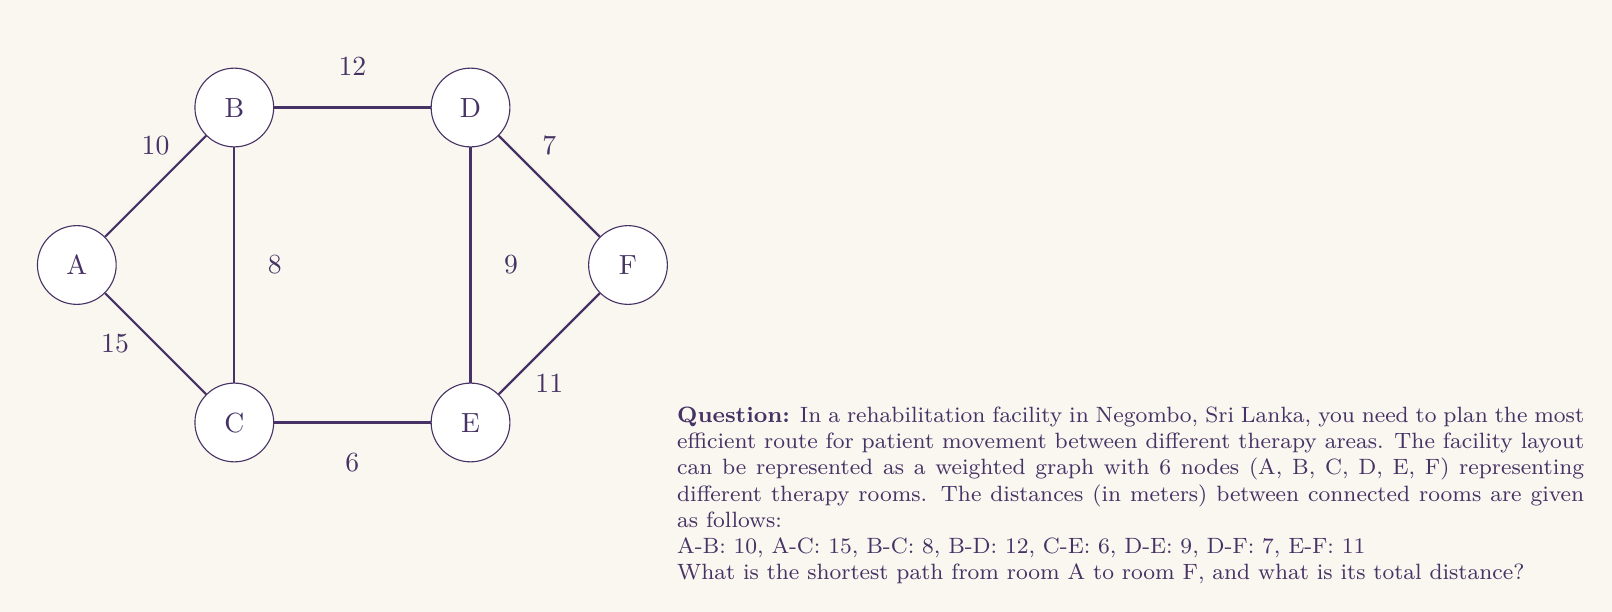Show me your answer to this math problem. To solve this problem, we can use Dijkstra's algorithm to find the shortest path from node A to node F. Let's go through the steps:

1) Initialize distances:
   A: 0 (starting node)
   B, C, D, E, F: $\infty$ (infinity)

2) Visit node A:
   Update distances:
   B: 10
   C: 15
   Next node: B (shortest unvisited)

3) Visit node B:
   Update distances:
   C: min(15, 10 + 8) = 15
   D: min($\infty$, 10 + 12) = 22
   Next node: C

4) Visit node C:
   Update distances:
   E: min($\infty$, 15 + 6) = 21
   Next node: E

5) Visit node E:
   Update distances:
   D: min(22, 21 + 9) = 21
   F: min($\infty$, 21 + 11) = 32
   Next node: D

6) Visit node D:
   Update distances:
   F: min(32, 21 + 7) = 28
   Next node: F

7) Visit node F:
   Algorithm complete

The shortest path is A -> B -> D -> F with a total distance of 29 meters.

To verify:
A to B: 10m
B to D: 12m
D to F: 7m
Total: 10 + 12 + 7 = 29m
Answer: The shortest path from room A to room F is A -> B -> D -> F, with a total distance of 29 meters. 